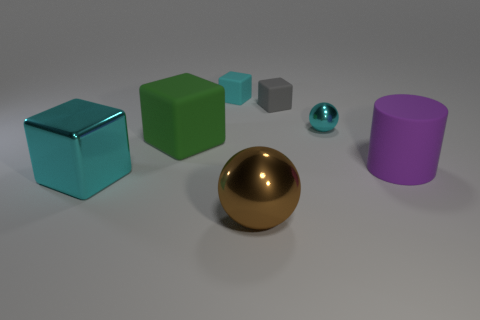Subtract all cyan blocks. How many were subtracted if there are1cyan blocks left? 1 Subtract 1 cubes. How many cubes are left? 3 Subtract all purple cubes. Subtract all red cylinders. How many cubes are left? 4 Add 1 purple cylinders. How many objects exist? 8 Subtract all balls. How many objects are left? 5 Subtract 0 yellow balls. How many objects are left? 7 Subtract all large green things. Subtract all rubber cylinders. How many objects are left? 5 Add 6 green things. How many green things are left? 7 Add 6 big purple rubber cylinders. How many big purple rubber cylinders exist? 7 